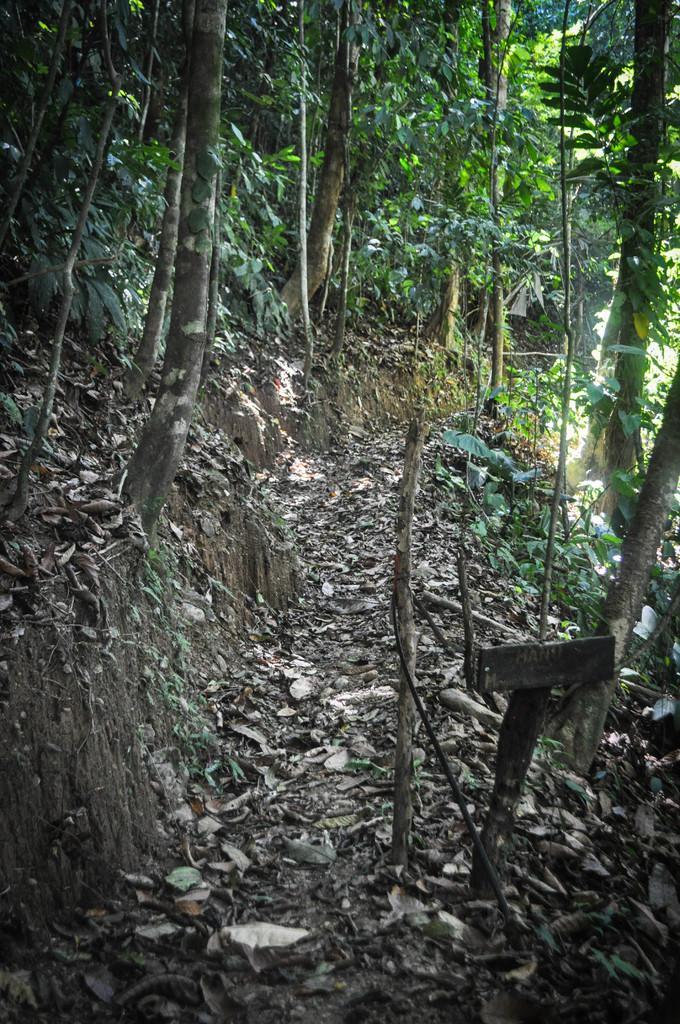How would you summarize this image in a sentence or two? In this image there are dry leaves on the ground and there are trees. 